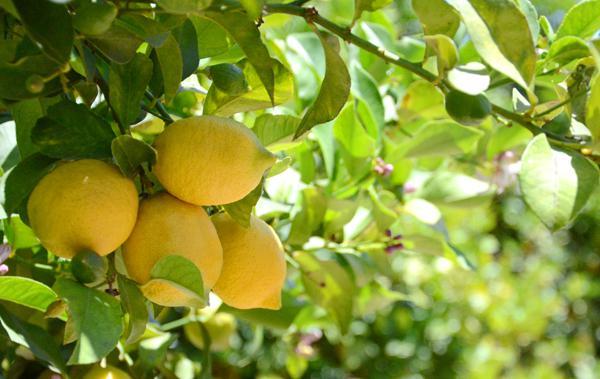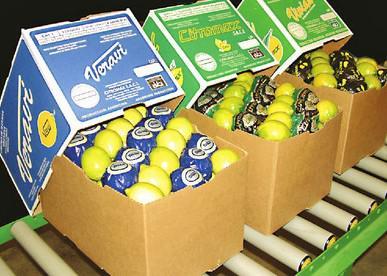The first image is the image on the left, the second image is the image on the right. Examine the images to the left and right. Is the description "There are lemons inside a box." accurate? Answer yes or no. Yes. The first image is the image on the left, the second image is the image on the right. For the images displayed, is the sentence "In at least one image there is a a cardboard box holding at least 6 rows of wrapped and unwrapped lemon." factually correct? Answer yes or no. Yes. 